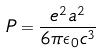Convert formula to latex. <formula><loc_0><loc_0><loc_500><loc_500>P = \frac { e ^ { 2 } a ^ { 2 } } { 6 \pi \epsilon _ { 0 } c ^ { 3 } }</formula> 